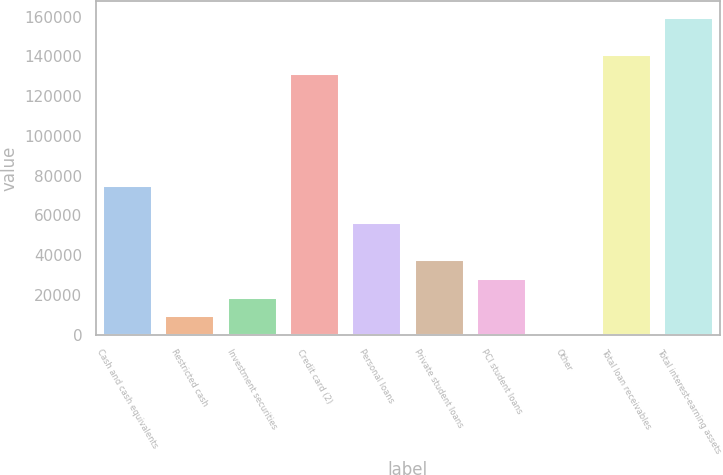<chart> <loc_0><loc_0><loc_500><loc_500><bar_chart><fcel>Cash and cash equivalents<fcel>Restricted cash<fcel>Investment securities<fcel>Credit card (2)<fcel>Personal loans<fcel>Private student loans<fcel>PCI student loans<fcel>Other<fcel>Total loan receivables<fcel>Total interest-earning assets<nl><fcel>75360.8<fcel>9714.1<fcel>19092.2<fcel>131629<fcel>56604.6<fcel>37848.4<fcel>28470.3<fcel>336<fcel>141008<fcel>159764<nl></chart> 